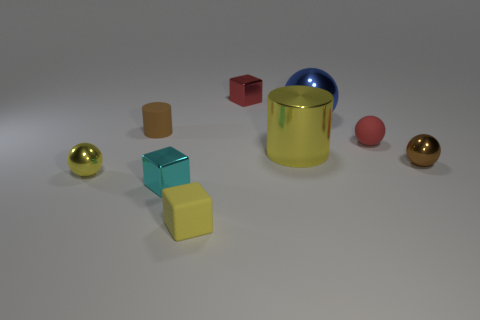Add 1 tiny blue cubes. How many objects exist? 10 Subtract all balls. How many objects are left? 5 Subtract all yellow matte balls. Subtract all large metal balls. How many objects are left? 8 Add 8 brown shiny balls. How many brown shiny balls are left? 9 Add 1 shiny cubes. How many shiny cubes exist? 3 Subtract 0 blue cubes. How many objects are left? 9 